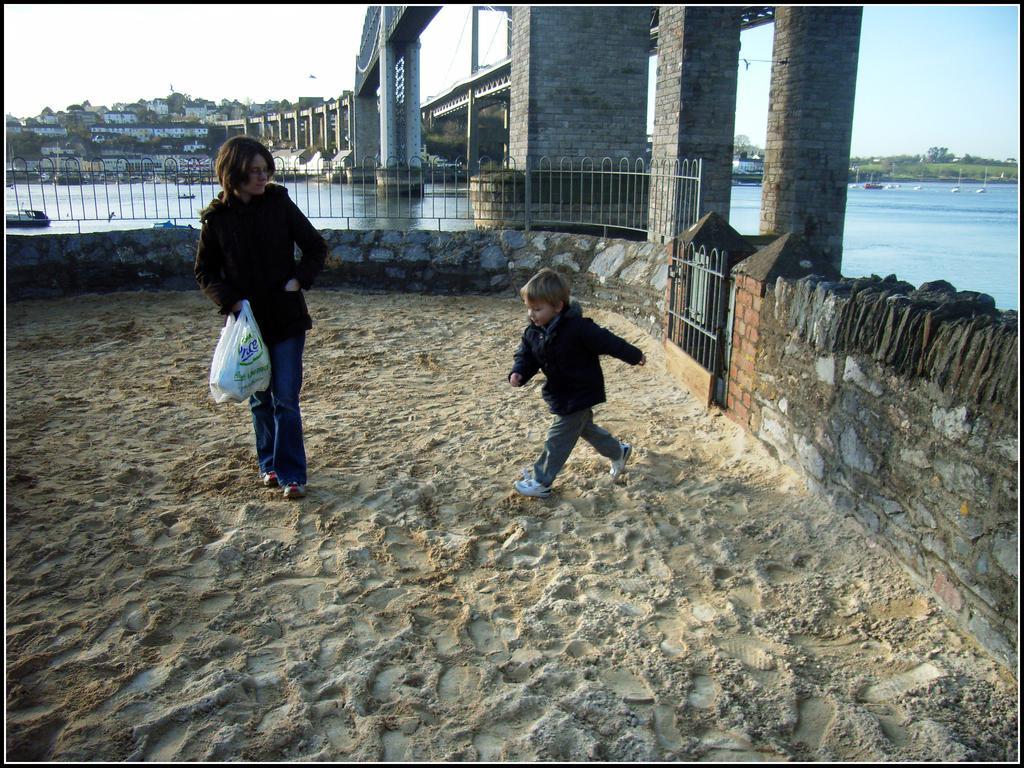How would you summarize this image in a sentence or two? In this image I can see a woman and a boy, I can see both of them are wearing jackets, shoes and jeans. I can also see she is holding a white colour plastic cover and I can see both of them are standing on the sand ground. In the background I can see water, number of buildings, a bridge, the sky, number of trees and few boats on the water. 